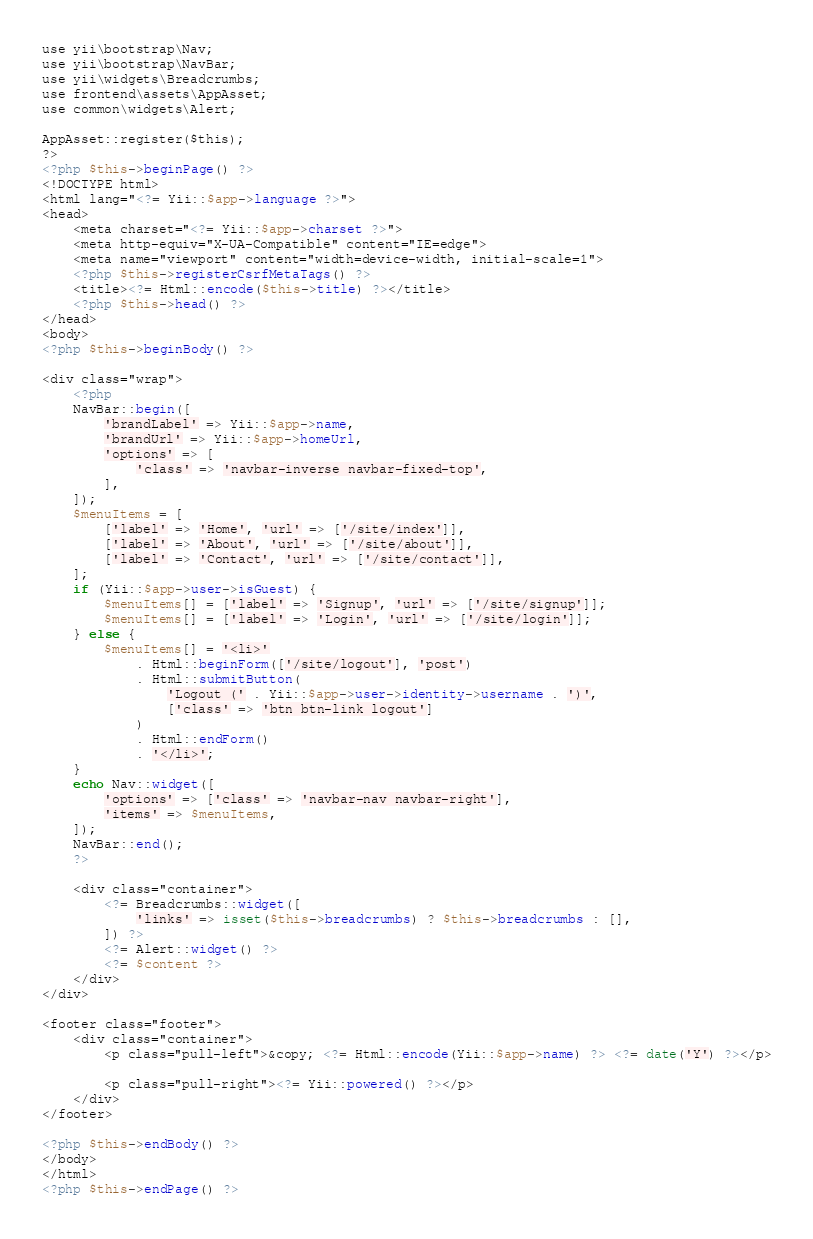Convert code to text. <code><loc_0><loc_0><loc_500><loc_500><_PHP_>use yii\bootstrap\Nav;
use yii\bootstrap\NavBar;
use yii\widgets\Breadcrumbs;
use frontend\assets\AppAsset;
use common\widgets\Alert;

AppAsset::register($this);
?>
<?php $this->beginPage() ?>
<!DOCTYPE html>
<html lang="<?= Yii::$app->language ?>">
<head>
    <meta charset="<?= Yii::$app->charset ?>">
    <meta http-equiv="X-UA-Compatible" content="IE=edge">
    <meta name="viewport" content="width=device-width, initial-scale=1">
    <?php $this->registerCsrfMetaTags() ?>
    <title><?= Html::encode($this->title) ?></title>
    <?php $this->head() ?>
</head>
<body>
<?php $this->beginBody() ?>

<div class="wrap">
    <?php
    NavBar::begin([
        'brandLabel' => Yii::$app->name,
        'brandUrl' => Yii::$app->homeUrl,
        'options' => [
            'class' => 'navbar-inverse navbar-fixed-top',
        ],
    ]);
    $menuItems = [
        ['label' => 'Home', 'url' => ['/site/index']],
        ['label' => 'About', 'url' => ['/site/about']],
        ['label' => 'Contact', 'url' => ['/site/contact']],
    ];
    if (Yii::$app->user->isGuest) {
        $menuItems[] = ['label' => 'Signup', 'url' => ['/site/signup']];
        $menuItems[] = ['label' => 'Login', 'url' => ['/site/login']];
    } else {
        $menuItems[] = '<li>'
            . Html::beginForm(['/site/logout'], 'post')
            . Html::submitButton(
                'Logout (' . Yii::$app->user->identity->username . ')',
                ['class' => 'btn btn-link logout']
            )
            . Html::endForm()
            . '</li>';
    }
    echo Nav::widget([
        'options' => ['class' => 'navbar-nav navbar-right'],
        'items' => $menuItems,
    ]);
    NavBar::end();
    ?>

    <div class="container">
        <?= Breadcrumbs::widget([
            'links' => isset($this->breadcrumbs) ? $this->breadcrumbs : [],
        ]) ?>
        <?= Alert::widget() ?>
        <?= $content ?>
    </div>
</div>

<footer class="footer">
    <div class="container">
        <p class="pull-left">&copy; <?= Html::encode(Yii::$app->name) ?> <?= date('Y') ?></p>

        <p class="pull-right"><?= Yii::powered() ?></p>
    </div>
</footer>

<?php $this->endBody() ?>
</body>
</html>
<?php $this->endPage() ?>
</code> 